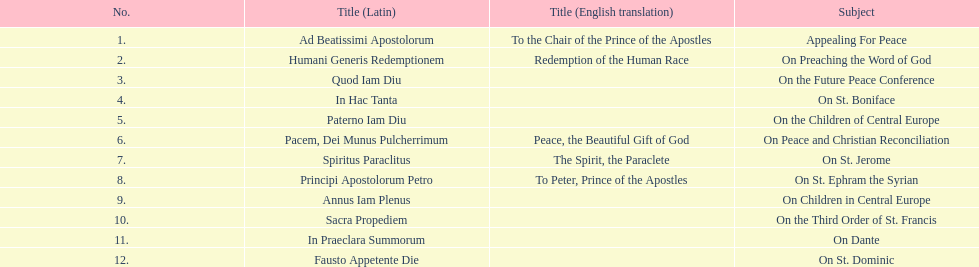How many titles were not provided with an english translation? 7. Parse the table in full. {'header': ['No.', 'Title (Latin)', 'Title (English translation)', 'Subject'], 'rows': [['1.', 'Ad Beatissimi Apostolorum', 'To the Chair of the Prince of the Apostles', 'Appealing For Peace'], ['2.', 'Humani Generis Redemptionem', 'Redemption of the Human Race', 'On Preaching the Word of God'], ['3.', 'Quod Iam Diu', '', 'On the Future Peace Conference'], ['4.', 'In Hac Tanta', '', 'On St. Boniface'], ['5.', 'Paterno Iam Diu', '', 'On the Children of Central Europe'], ['6.', 'Pacem, Dei Munus Pulcherrimum', 'Peace, the Beautiful Gift of God', 'On Peace and Christian Reconciliation'], ['7.', 'Spiritus Paraclitus', 'The Spirit, the Paraclete', 'On St. Jerome'], ['8.', 'Principi Apostolorum Petro', 'To Peter, Prince of the Apostles', 'On St. Ephram the Syrian'], ['9.', 'Annus Iam Plenus', '', 'On Children in Central Europe'], ['10.', 'Sacra Propediem', '', 'On the Third Order of St. Francis'], ['11.', 'In Praeclara Summorum', '', 'On Dante'], ['12.', 'Fausto Appetente Die', '', 'On St. Dominic']]} 